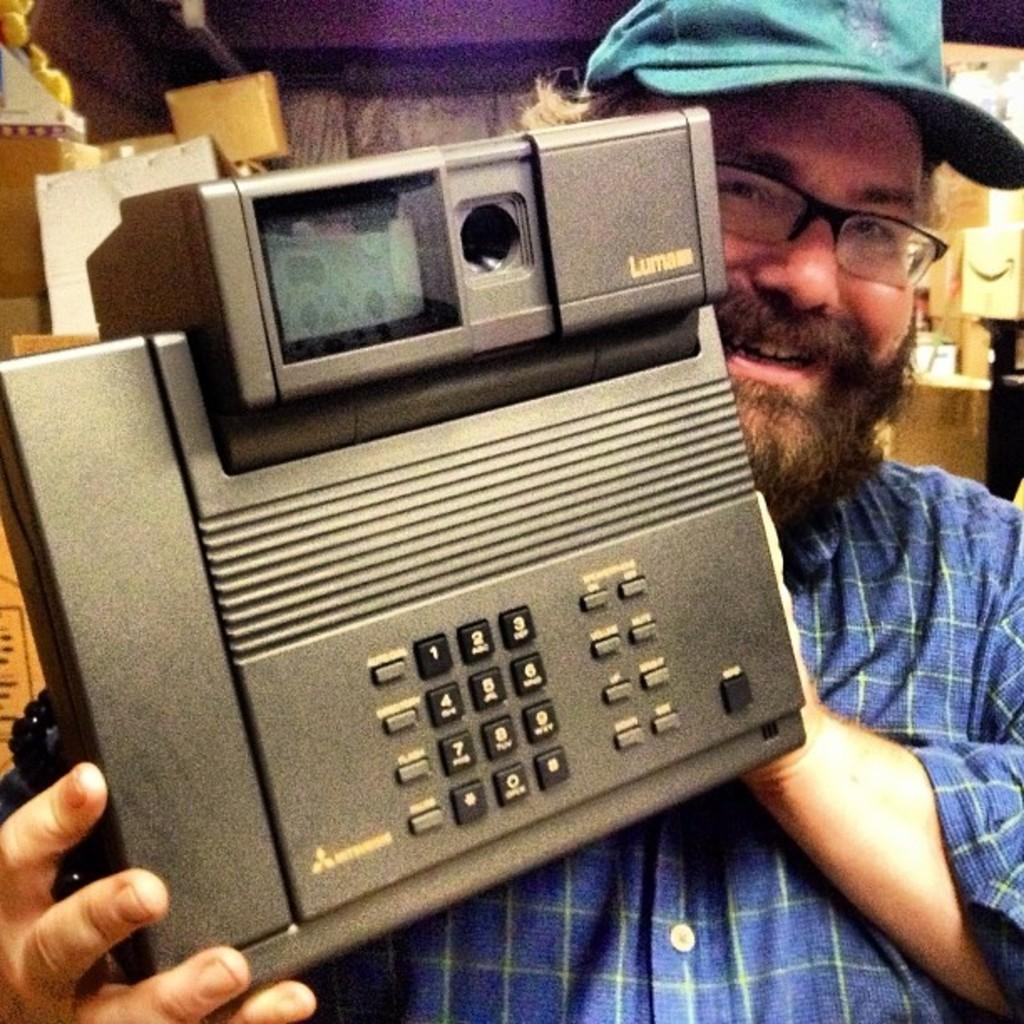Who or what is present in the image? There is a person in the image. What is the person doing in the image? The person is smiling. What object is the person holding in the image? The person is holding a telephone in his hand. What can be seen in the background of the image? There are objects in the background of the image. How many legs does the kitten have in the image? There is no kitten present in the image, so it is not possible to determine the number of legs it might have. 